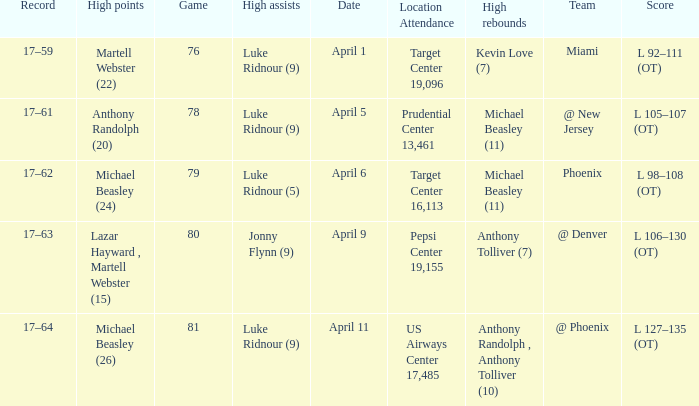Who did the most high rebounds on April 6? Michael Beasley (11). 